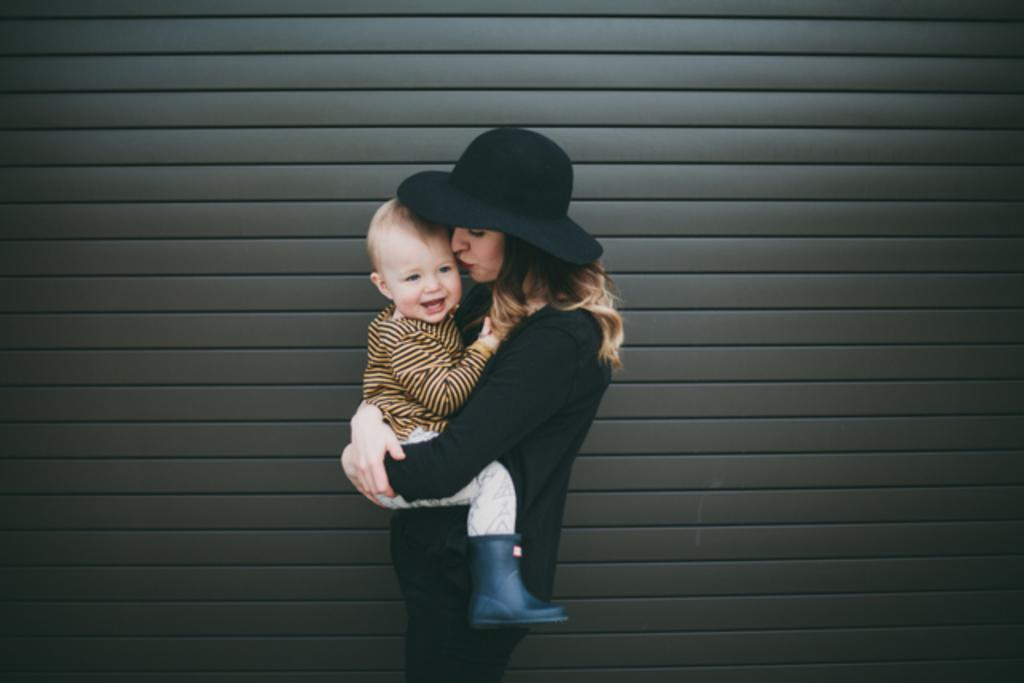Who is the main subject in the image? There is a woman in the image. What is the woman wearing on her head? The woman is wearing a hat. What is the woman doing in the image? The woman is carrying a baby. How does the baby appear in the image? The baby is smiling. What is the color of the background in the image? The background color is brown. What type of wire is being used to support the scarecrow in the image? There is no wire or scarecrow present in the image. 